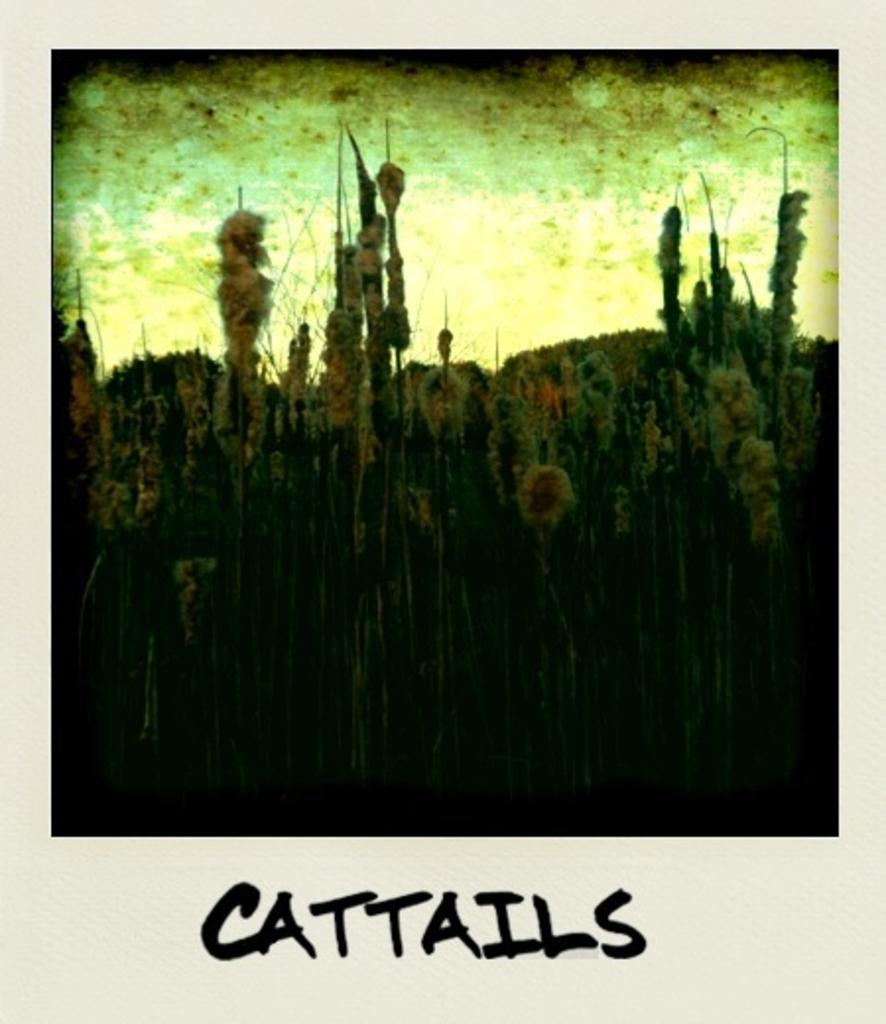What is the main subject of the image? There is a photograph in the image. What is depicted in the photograph? The photograph contains flowers and plants. Is there any text in the photograph? Yes, there is text at the bottom of the photograph. How many houses are visible in the photograph? There are no houses visible in the photograph; it contains flowers and plants. Can you see a person standing on the roof in the photograph? There is no person or roof present in the photograph. 